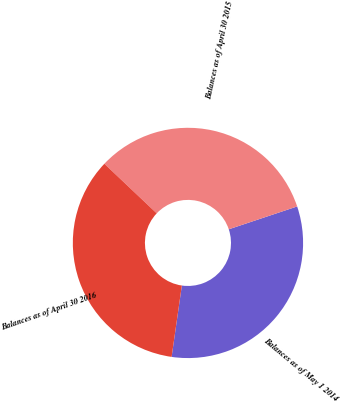<chart> <loc_0><loc_0><loc_500><loc_500><pie_chart><fcel>Balances as of May 1 2014<fcel>Balances as of April 30 2015<fcel>Balances as of April 30 2016<nl><fcel>32.4%<fcel>32.8%<fcel>34.8%<nl></chart> 